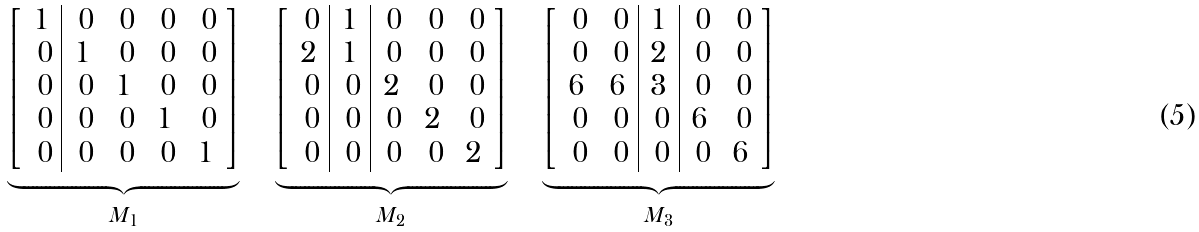Convert formula to latex. <formula><loc_0><loc_0><loc_500><loc_500>\underbrace { \left [ \begin{array} { c | c c c c } 1 & \ 0 & \ 0 & \ 0 & \ 0 \\ \ 0 & 1 & \ 0 & \ 0 & \ 0 \\ \ 0 & \ 0 & 1 & \ 0 & \ 0 \\ \ 0 & \ 0 & \ 0 & 1 & \ 0 \\ \ 0 & \ 0 & \ 0 & \ 0 & 1 \end{array} \right ] } _ { M _ { 1 } } \quad \underbrace { \left [ \begin{array} { c | c | c c c } \ 0 & 1 & \ 0 & \ 0 & \ 0 \\ 2 & 1 & \ 0 & \ 0 & \ 0 \\ \ 0 & \ 0 & 2 & \ 0 & \ 0 \\ \ 0 & \ 0 & \ 0 & 2 & \ 0 \\ \ 0 & \ 0 & \ 0 & \ 0 & 2 \end{array} \right ] } _ { M _ { 2 } } \quad \underbrace { \left [ \begin{array} { c c | c | c c } \ 0 & \ 0 & 1 & \ 0 & \ 0 \\ \ 0 & \ 0 & 2 & \ 0 & \ 0 \\ 6 & 6 & 3 & \ 0 & \ 0 \\ \ 0 & \ 0 & \ 0 & 6 & \ 0 \\ \ 0 & \ 0 & \ 0 & \ 0 & 6 \end{array} \right ] } _ { M _ { 3 } }</formula> 